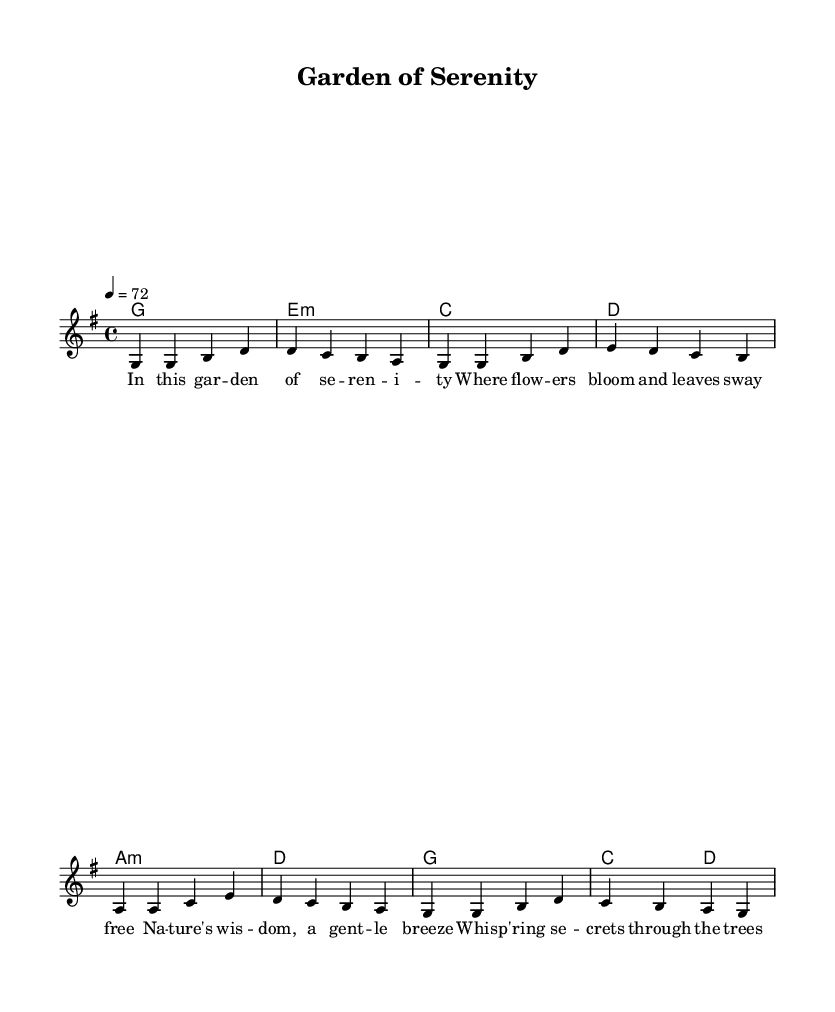What is the key signature of this music? The key signature is G major, which has one sharp (F#). This is indicated at the beginning of the staff.
Answer: G major What is the time signature of this music? The time signature is 4/4, which means there are four beats in each measure and the quarter note gets one beat. This is shown at the beginning of the sheet music.
Answer: 4/4 What is the tempo marking for this piece? The tempo is marked as 72 beats per minute, which indicates the speed of the music. This is noted at the beginning of the score, specifically under the global settings.
Answer: 72 How many measures are in the melody? The melody consists of 8 measures, which can be counted by looking at the vertical bar lines that separate the measures.
Answer: 8 What is the first lyric line of the verse? The first lyric line is "In this gar -- den of se -- ren -- i -- ty". This can be found in the lyric section aligned with the melody notes.
Answer: In this gar -- den of se -- ren -- i -- ty Which chord follows the A minor chord in the harmonies? The chord that follows A minor is D major, which can be identified by examining the sequence of chords listed in the harmonies section.
Answer: D major What is the overall theme of the lyrics? The overall theme of the lyrics expresses a connection with nature and tranquility, as indicated by words like "garden," "breeze," and "trees." This reflects the nature-inspired basis of the song.
Answer: Nature and tranquility 